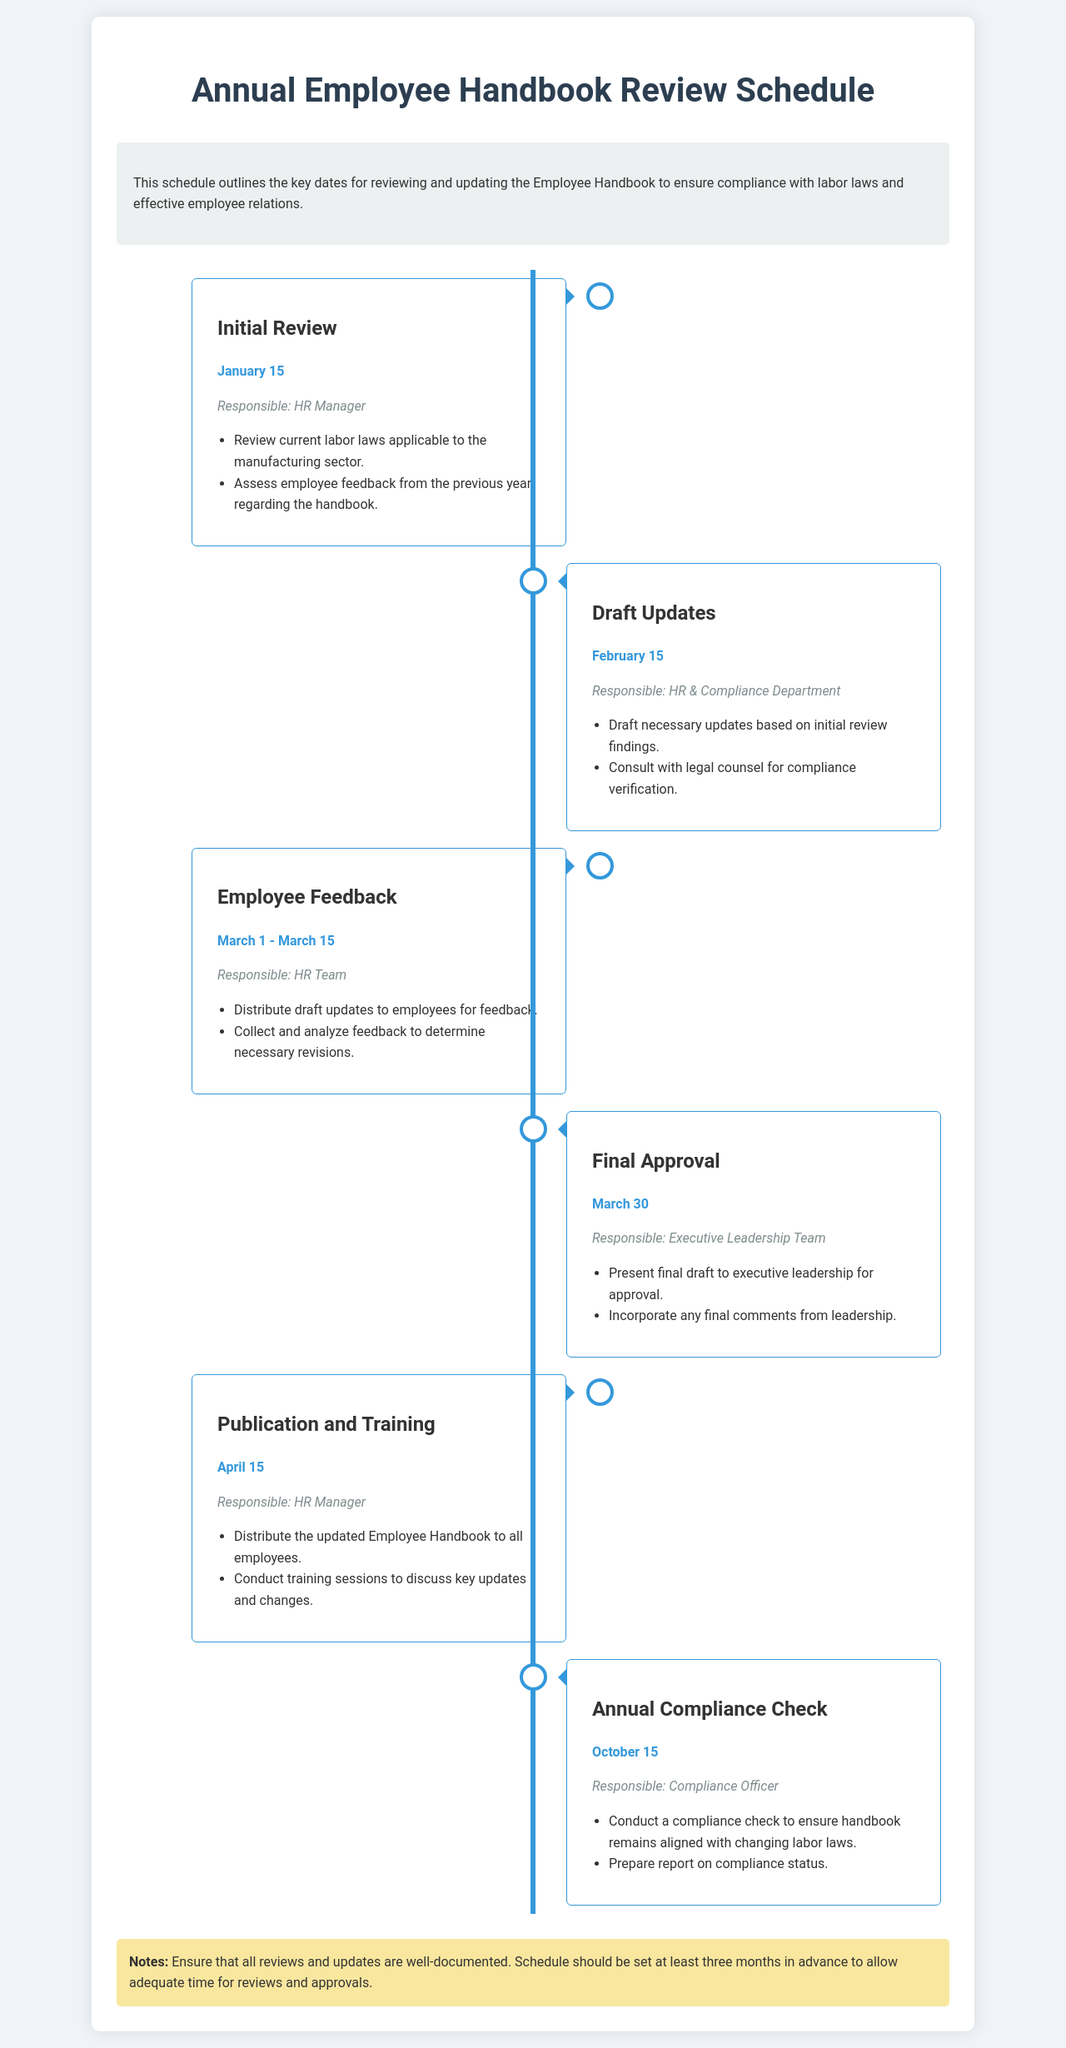What is the first review date? The first review date is specified in the schedule under "Initial Review," which is on January 15.
Answer: January 15 Who is responsible for the final approval? The schedule indicates that the final approval is the responsibility of the Executive Leadership Team.
Answer: Executive Leadership Team What date is set for employee feedback? The timeframe for employee feedback is stated in "Employee Feedback," which occurs from March 1 to March 15.
Answer: March 1 - March 15 When will the updated handbook be published? The publication date for the updated Employee Handbook is found under "Publication and Training," which is April 15.
Answer: April 15 What is the purpose of the annual compliance check? It is defined as ensuring the handbook remains aligned with changing labor laws and preparing a compliance status report.
Answer: Compliance check What is the final deadline for updates to be presented to leadership? The last date mentioned for this action is March 30 under "Final Approval."
Answer: March 30 Who is tasked with the initial review? The responsible party for the initial review, as stated in the schedule, is the HR Manager.
Answer: HR Manager How long is the period for collecting employee feedback? The schedule specifies the duration for collecting employee feedback lasts for 15 days.
Answer: 15 days What should be ensured with all reviews and updates? The schedule instructs that all reviews and updates should be well-documented.
Answer: Well-documented 